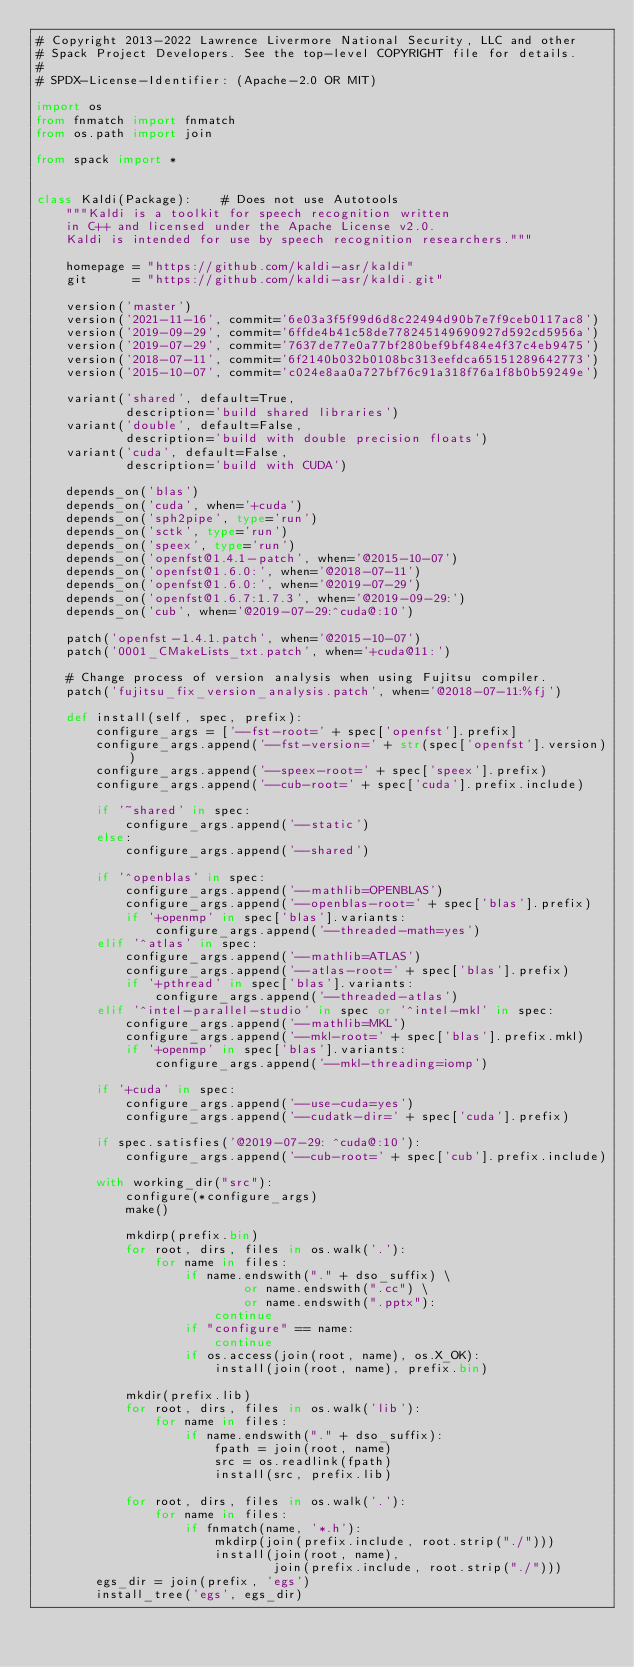<code> <loc_0><loc_0><loc_500><loc_500><_Python_># Copyright 2013-2022 Lawrence Livermore National Security, LLC and other
# Spack Project Developers. See the top-level COPYRIGHT file for details.
#
# SPDX-License-Identifier: (Apache-2.0 OR MIT)

import os
from fnmatch import fnmatch
from os.path import join

from spack import *


class Kaldi(Package):    # Does not use Autotools
    """Kaldi is a toolkit for speech recognition written
    in C++ and licensed under the Apache License v2.0.
    Kaldi is intended for use by speech recognition researchers."""

    homepage = "https://github.com/kaldi-asr/kaldi"
    git      = "https://github.com/kaldi-asr/kaldi.git"

    version('master')
    version('2021-11-16', commit='6e03a3f5f99d6d8c22494d90b7e7f9ceb0117ac8')
    version('2019-09-29', commit='6ffde4b41c58de778245149690927d592cd5956a')
    version('2019-07-29', commit='7637de77e0a77bf280bef9bf484e4f37c4eb9475')
    version('2018-07-11', commit='6f2140b032b0108bc313eefdca65151289642773')
    version('2015-10-07', commit='c024e8aa0a727bf76c91a318f76a1f8b0b59249e')

    variant('shared', default=True,
            description='build shared libraries')
    variant('double', default=False,
            description='build with double precision floats')
    variant('cuda', default=False,
            description='build with CUDA')

    depends_on('blas')
    depends_on('cuda', when='+cuda')
    depends_on('sph2pipe', type='run')
    depends_on('sctk', type='run')
    depends_on('speex', type='run')
    depends_on('openfst@1.4.1-patch', when='@2015-10-07')
    depends_on('openfst@1.6.0:', when='@2018-07-11')
    depends_on('openfst@1.6.0:', when='@2019-07-29')
    depends_on('openfst@1.6.7:1.7.3', when='@2019-09-29:')
    depends_on('cub', when='@2019-07-29:^cuda@:10')

    patch('openfst-1.4.1.patch', when='@2015-10-07')
    patch('0001_CMakeLists_txt.patch', when='+cuda@11:')

    # Change process of version analysis when using Fujitsu compiler.
    patch('fujitsu_fix_version_analysis.patch', when='@2018-07-11:%fj')

    def install(self, spec, prefix):
        configure_args = ['--fst-root=' + spec['openfst'].prefix]
        configure_args.append('--fst-version=' + str(spec['openfst'].version))
        configure_args.append('--speex-root=' + spec['speex'].prefix)
        configure_args.append('--cub-root=' + spec['cuda'].prefix.include)

        if '~shared' in spec:
            configure_args.append('--static')
        else:
            configure_args.append('--shared')

        if '^openblas' in spec:
            configure_args.append('--mathlib=OPENBLAS')
            configure_args.append('--openblas-root=' + spec['blas'].prefix)
            if '+openmp' in spec['blas'].variants:
                configure_args.append('--threaded-math=yes')
        elif '^atlas' in spec:
            configure_args.append('--mathlib=ATLAS')
            configure_args.append('--atlas-root=' + spec['blas'].prefix)
            if '+pthread' in spec['blas'].variants:
                configure_args.append('--threaded-atlas')
        elif '^intel-parallel-studio' in spec or '^intel-mkl' in spec:
            configure_args.append('--mathlib=MKL')
            configure_args.append('--mkl-root=' + spec['blas'].prefix.mkl)
            if '+openmp' in spec['blas'].variants:
                configure_args.append('--mkl-threading=iomp')

        if '+cuda' in spec:
            configure_args.append('--use-cuda=yes')
            configure_args.append('--cudatk-dir=' + spec['cuda'].prefix)

        if spec.satisfies('@2019-07-29: ^cuda@:10'):
            configure_args.append('--cub-root=' + spec['cub'].prefix.include)

        with working_dir("src"):
            configure(*configure_args)
            make()

            mkdirp(prefix.bin)
            for root, dirs, files in os.walk('.'):
                for name in files:
                    if name.endswith("." + dso_suffix) \
                            or name.endswith(".cc") \
                            or name.endswith(".pptx"):
                        continue
                    if "configure" == name:
                        continue
                    if os.access(join(root, name), os.X_OK):
                        install(join(root, name), prefix.bin)

            mkdir(prefix.lib)
            for root, dirs, files in os.walk('lib'):
                for name in files:
                    if name.endswith("." + dso_suffix):
                        fpath = join(root, name)
                        src = os.readlink(fpath)
                        install(src, prefix.lib)

            for root, dirs, files in os.walk('.'):
                for name in files:
                    if fnmatch(name, '*.h'):
                        mkdirp(join(prefix.include, root.strip("./")))
                        install(join(root, name),
                                join(prefix.include, root.strip("./")))
        egs_dir = join(prefix, 'egs')
        install_tree('egs', egs_dir)
</code> 